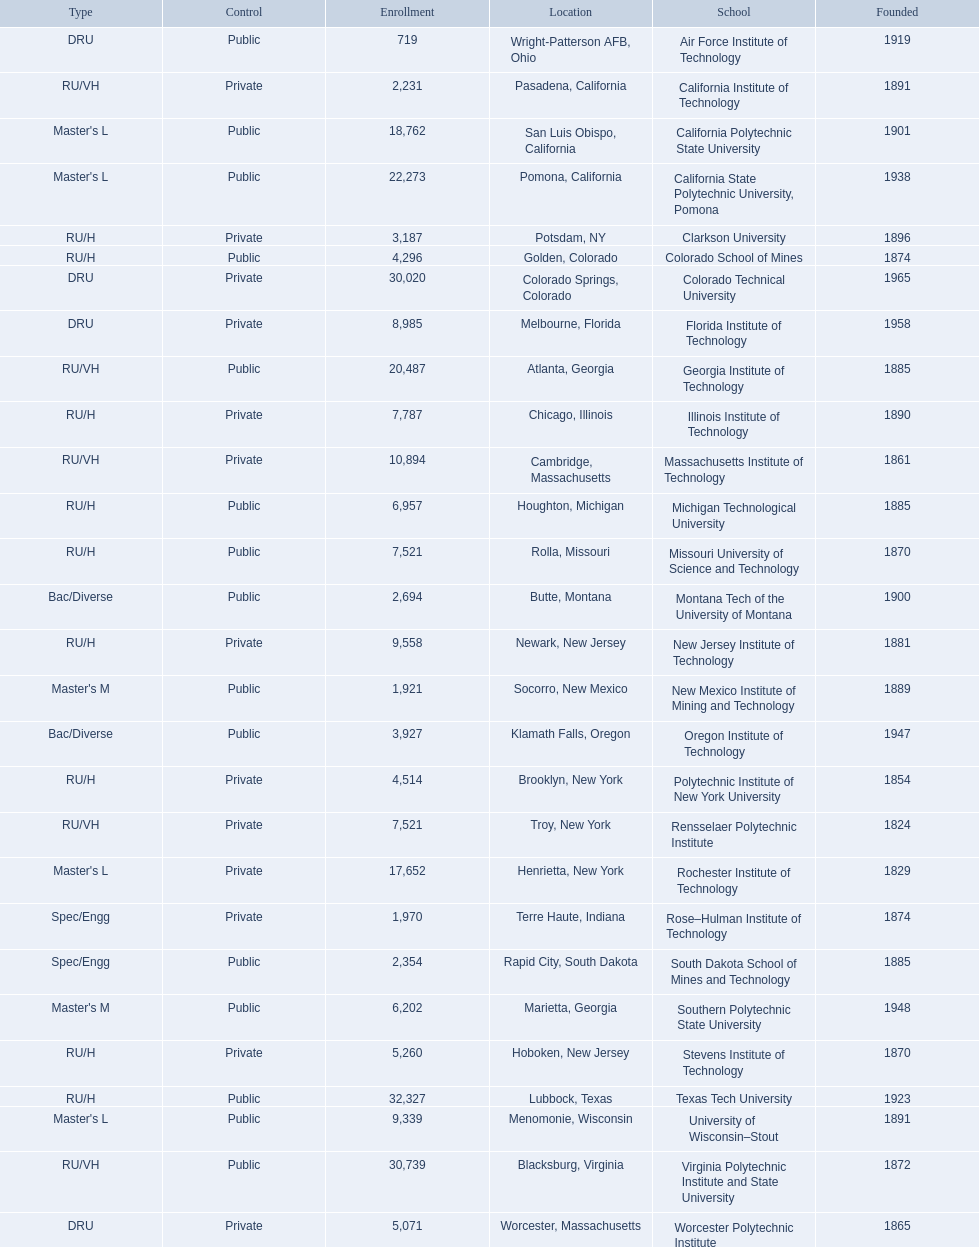What are all the schools? Air Force Institute of Technology, California Institute of Technology, California Polytechnic State University, California State Polytechnic University, Pomona, Clarkson University, Colorado School of Mines, Colorado Technical University, Florida Institute of Technology, Georgia Institute of Technology, Illinois Institute of Technology, Massachusetts Institute of Technology, Michigan Technological University, Missouri University of Science and Technology, Montana Tech of the University of Montana, New Jersey Institute of Technology, New Mexico Institute of Mining and Technology, Oregon Institute of Technology, Polytechnic Institute of New York University, Rensselaer Polytechnic Institute, Rochester Institute of Technology, Rose–Hulman Institute of Technology, South Dakota School of Mines and Technology, Southern Polytechnic State University, Stevens Institute of Technology, Texas Tech University, University of Wisconsin–Stout, Virginia Polytechnic Institute and State University, Worcester Polytechnic Institute. What is the enrollment of each school? 719, 2,231, 18,762, 22,273, 3,187, 4,296, 30,020, 8,985, 20,487, 7,787, 10,894, 6,957, 7,521, 2,694, 9,558, 1,921, 3,927, 4,514, 7,521, 17,652, 1,970, 2,354, 6,202, 5,260, 32,327, 9,339, 30,739, 5,071. And which school had the highest enrollment? Texas Tech University. What are the listed enrollment numbers of us universities? 719, 2,231, 18,762, 22,273, 3,187, 4,296, 30,020, 8,985, 20,487, 7,787, 10,894, 6,957, 7,521, 2,694, 9,558, 1,921, 3,927, 4,514, 7,521, 17,652, 1,970, 2,354, 6,202, 5,260, 32,327, 9,339, 30,739, 5,071. Of these, which has the highest value? 32,327. What are the listed names of us universities? Air Force Institute of Technology, California Institute of Technology, California Polytechnic State University, California State Polytechnic University, Pomona, Clarkson University, Colorado School of Mines, Colorado Technical University, Florida Institute of Technology, Georgia Institute of Technology, Illinois Institute of Technology, Massachusetts Institute of Technology, Michigan Technological University, Missouri University of Science and Technology, Montana Tech of the University of Montana, New Jersey Institute of Technology, New Mexico Institute of Mining and Technology, Oregon Institute of Technology, Polytechnic Institute of New York University, Rensselaer Polytechnic Institute, Rochester Institute of Technology, Rose–Hulman Institute of Technology, South Dakota School of Mines and Technology, Southern Polytechnic State University, Stevens Institute of Technology, Texas Tech University, University of Wisconsin–Stout, Virginia Polytechnic Institute and State University, Worcester Polytechnic Institute. Which of these correspond to the previously listed highest enrollment value? Texas Tech University. 